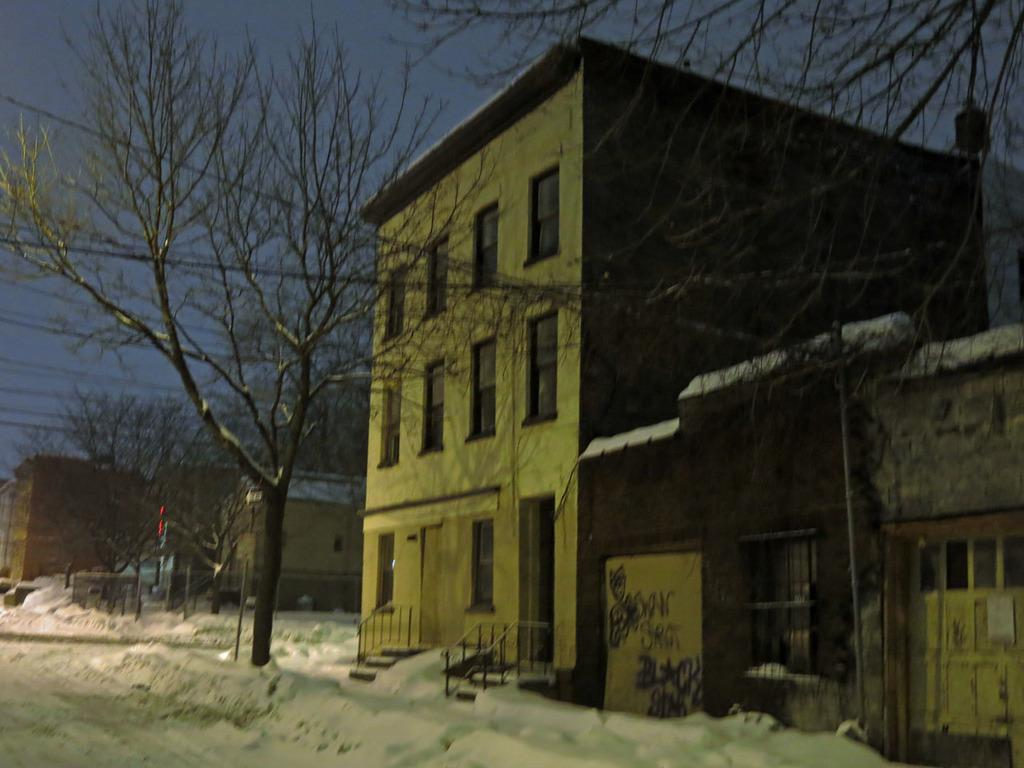What type of vegetation can be seen in the image? There are trees in the image. What type of structures are visible in the image? There are buildings with windows in the image. What else can be seen in the image besides trees and buildings? There are wires in the image. What is visible in the background of the image? The sky is visible in the background of the image. What can be observed in the sky? Clouds are present in the sky. Can you see any dinosaurs roaming around in the image? There are no dinosaurs present in the image. What type of roof is visible on the buildings in the image? The provided facts do not mention any roofs on the buildings, so we cannot answer this question definitively. 